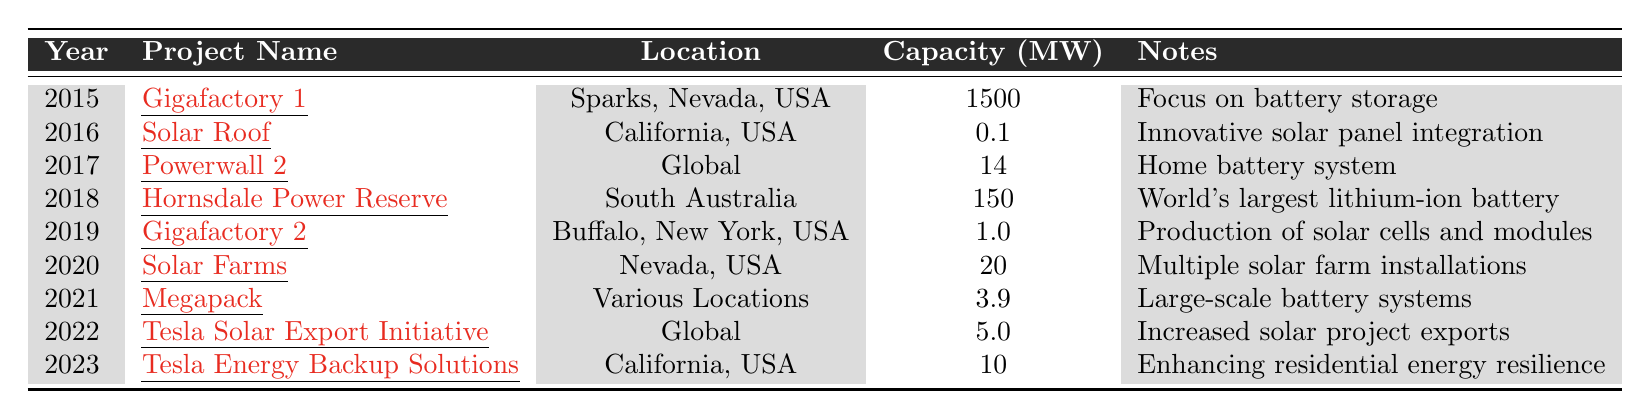What project had the highest capacity in megawatts? The table shows that "Gigafactory 1" has a capacity of 1500 MW, which is much higher than any other project listed.
Answer: 1500 MW In what year did Tesla launch the "Solar Roof" project? Referring to the table, "Solar Roof" was launched in the year 2016.
Answer: 2016 How much energy did the "Powerwall 2" project produce in TWh? According to the table, the "Powerwall 2" produced 3.3 TWh of energy.
Answer: 3.3 TWh What is the average capacity of the renewable energy projects listed from 2015 to 2023? To find the average, sum the capacities (1500 + 0.1 + 14 + 150 + 1.0 + 20 + 3.9 + 5.0 + 10) = 1704; then divide by the 9 projects: 1704 / 9 ≈ 189.33.
Answer: Approximately 189.33 MW True or false: The "Hornsdale Power Reserve" project is located in the USA. The table indicates that "Hornsdale Power Reserve" is located in South Australia, which is not in the USA.
Answer: False Which project produced the least amount of energy from 2015 to 2023? From the listed projects, the "Solar Roof" produced only 0.015 TWh, the least of any project.
Answer: "Solar Roof" What was the total energy produced by all projects from 2015 to 2023? The total energy is calculated by adding all values (0.54 + 0.015 + 3.3 + 0.5 + 0.030 + 0.045 + 0.1 + 0.2 + 0.12) = 4.84 TWh.
Answer: 4.84 TWh Which project, initiated in 2022, aimed to increase solar project exports? According to the table, the "Tesla Solar Export Initiative" started in 2022 with the goal of enhancing solar project exports.
Answer: "Tesla Solar Export Initiative" How many total projects had a capacity greater than 10 MW? From the table, "Gigafactory 1" (1500 MW), "Hornsdale Power Reserve" (150 MW), and "Powerwall 2" (14 MW) are the only projects over 10 MW, totaling 3 projects.
Answer: 3 projects What year showed significant improvement in energy production compared to the previous year? Looking closely, 2017 with the "Powerwall 2" (3.3 TWh) compared to 2016's "Solar Roof" (0.015 TWh) shows a massive increase, indicating significant improvement.
Answer: 2017 